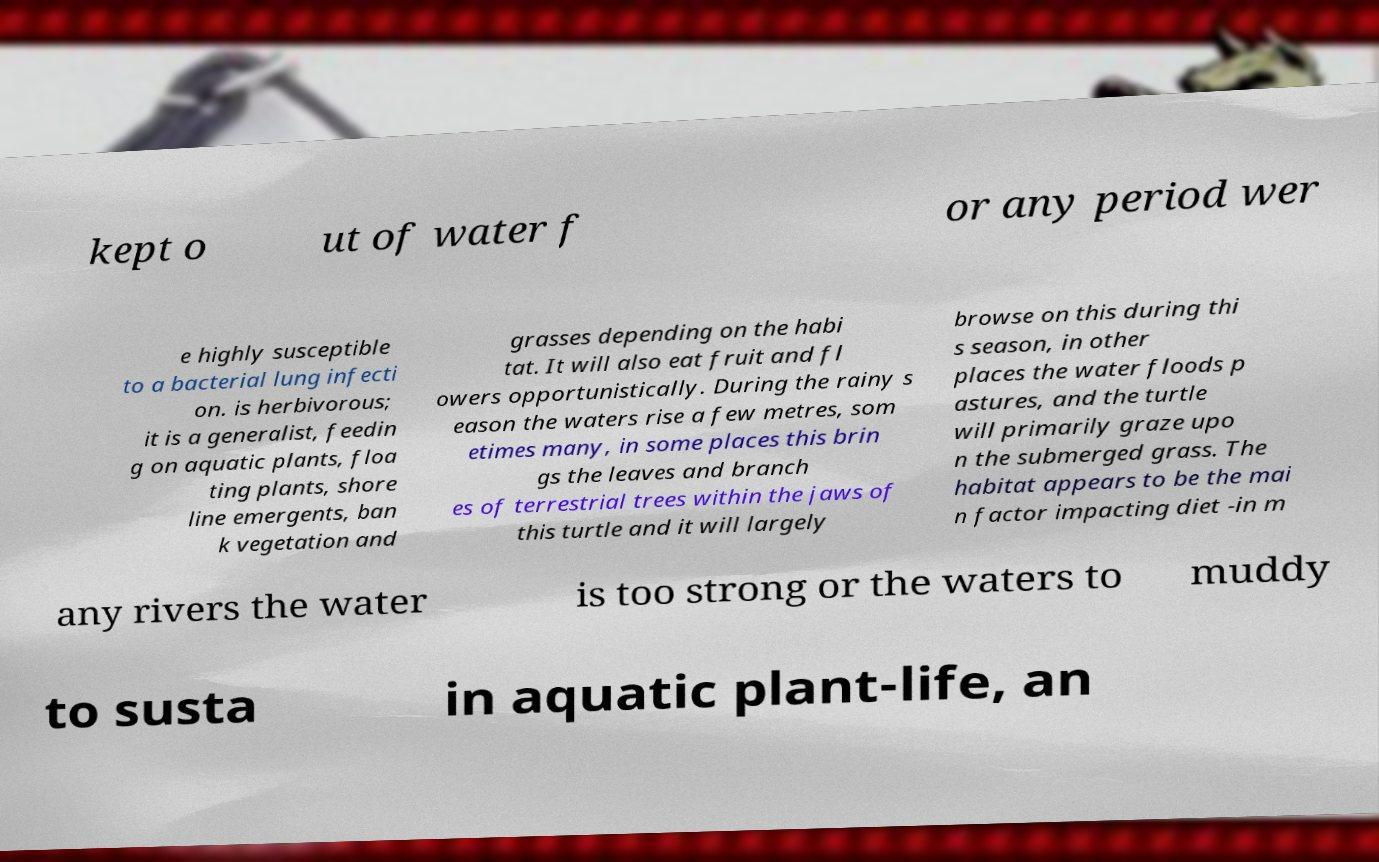There's text embedded in this image that I need extracted. Can you transcribe it verbatim? kept o ut of water f or any period wer e highly susceptible to a bacterial lung infecti on. is herbivorous; it is a generalist, feedin g on aquatic plants, floa ting plants, shore line emergents, ban k vegetation and grasses depending on the habi tat. It will also eat fruit and fl owers opportunistically. During the rainy s eason the waters rise a few metres, som etimes many, in some places this brin gs the leaves and branch es of terrestrial trees within the jaws of this turtle and it will largely browse on this during thi s season, in other places the water floods p astures, and the turtle will primarily graze upo n the submerged grass. The habitat appears to be the mai n factor impacting diet -in m any rivers the water is too strong or the waters to muddy to susta in aquatic plant-life, an 